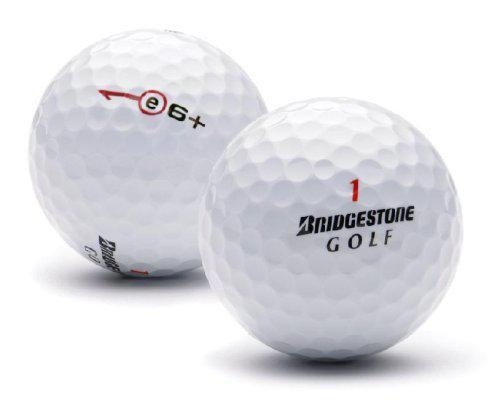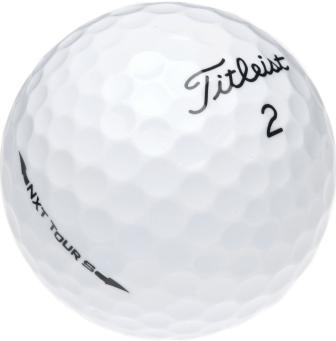The first image is the image on the left, the second image is the image on the right. Given the left and right images, does the statement "The balls in at least one of the images are set on the grass." hold true? Answer yes or no. No. 